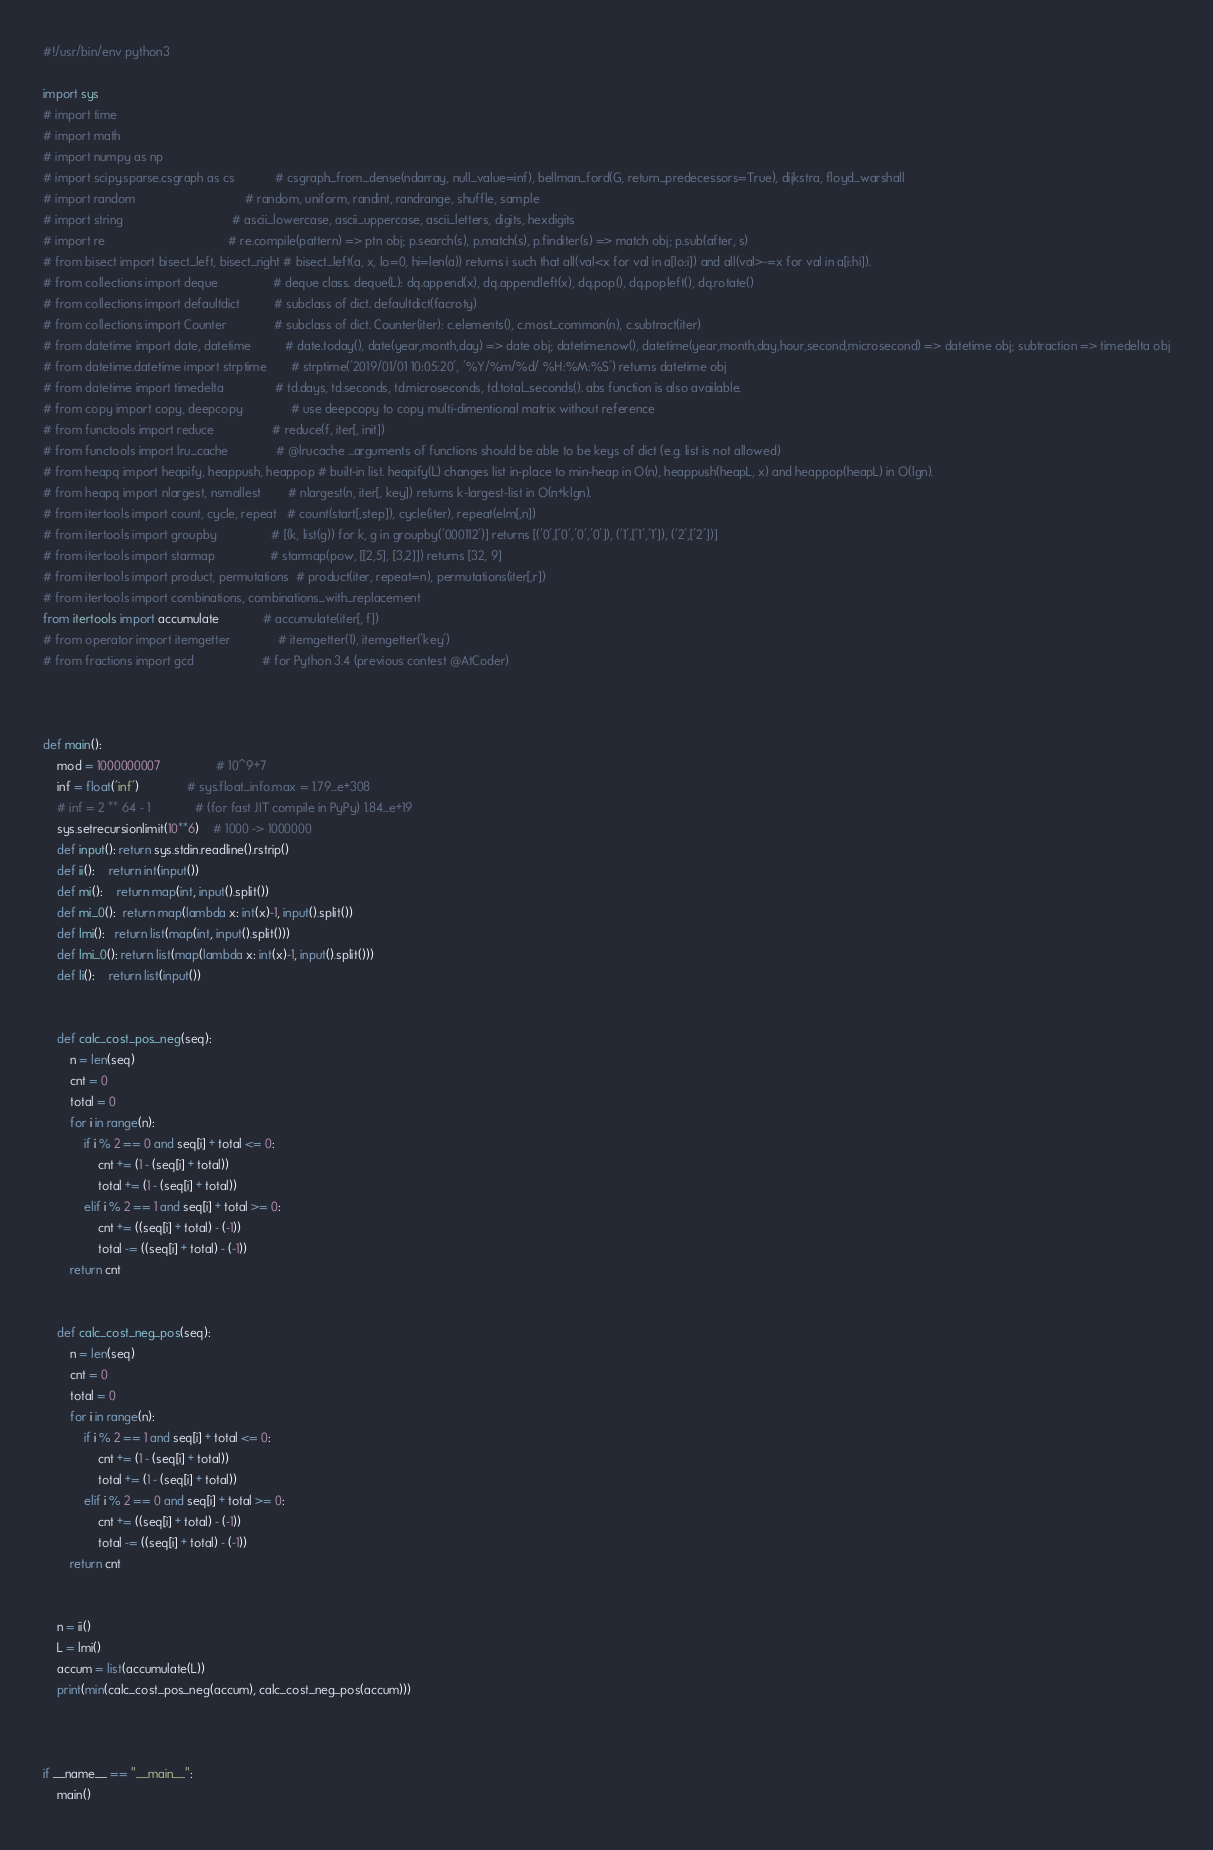<code> <loc_0><loc_0><loc_500><loc_500><_Python_>#!/usr/bin/env python3

import sys
# import time
# import math
# import numpy as np
# import scipy.sparse.csgraph as cs            # csgraph_from_dense(ndarray, null_value=inf), bellman_ford(G, return_predecessors=True), dijkstra, floyd_warshall
# import random                                # random, uniform, randint, randrange, shuffle, sample
# import string                                # ascii_lowercase, ascii_uppercase, ascii_letters, digits, hexdigits
# import re                                    # re.compile(pattern) => ptn obj; p.search(s), p.match(s), p.finditer(s) => match obj; p.sub(after, s)
# from bisect import bisect_left, bisect_right # bisect_left(a, x, lo=0, hi=len(a)) returns i such that all(val<x for val in a[lo:i]) and all(val>-=x for val in a[i:hi]).
# from collections import deque                # deque class. deque(L): dq.append(x), dq.appendleft(x), dq.pop(), dq.popleft(), dq.rotate()
# from collections import defaultdict          # subclass of dict. defaultdict(facroty)
# from collections import Counter              # subclass of dict. Counter(iter): c.elements(), c.most_common(n), c.subtract(iter)
# from datetime import date, datetime          # date.today(), date(year,month,day) => date obj; datetime.now(), datetime(year,month,day,hour,second,microsecond) => datetime obj; subtraction => timedelta obj
# from datetime.datetime import strptime       # strptime('2019/01/01 10:05:20', '%Y/%m/%d/ %H:%M:%S') returns datetime obj
# from datetime import timedelta               # td.days, td.seconds, td.microseconds, td.total_seconds(). abs function is also available.
# from copy import copy, deepcopy              # use deepcopy to copy multi-dimentional matrix without reference
# from functools import reduce                 # reduce(f, iter[, init])
# from functools import lru_cache              # @lrucache ...arguments of functions should be able to be keys of dict (e.g. list is not allowed)
# from heapq import heapify, heappush, heappop # built-in list. heapify(L) changes list in-place to min-heap in O(n), heappush(heapL, x) and heappop(heapL) in O(lgn).
# from heapq import nlargest, nsmallest        # nlargest(n, iter[, key]) returns k-largest-list in O(n+klgn).
# from itertools import count, cycle, repeat   # count(start[,step]), cycle(iter), repeat(elm[,n])
# from itertools import groupby                # [(k, list(g)) for k, g in groupby('000112')] returns [('0',['0','0','0']), ('1',['1','1']), ('2',['2'])]
# from itertools import starmap                # starmap(pow, [[2,5], [3,2]]) returns [32, 9]
# from itertools import product, permutations  # product(iter, repeat=n), permutations(iter[,r])
# from itertools import combinations, combinations_with_replacement
from itertools import accumulate             # accumulate(iter[, f])
# from operator import itemgetter              # itemgetter(1), itemgetter('key')
# from fractions import gcd                    # for Python 3.4 (previous contest @AtCoder)



def main():
    mod = 1000000007                # 10^9+7
    inf = float('inf')              # sys.float_info.max = 1.79...e+308
    # inf = 2 ** 64 - 1             # (for fast JIT compile in PyPy) 1.84...e+19
    sys.setrecursionlimit(10**6)    # 1000 -> 1000000
    def input(): return sys.stdin.readline().rstrip()
    def ii():    return int(input())
    def mi():    return map(int, input().split())
    def mi_0():  return map(lambda x: int(x)-1, input().split())
    def lmi():   return list(map(int, input().split()))
    def lmi_0(): return list(map(lambda x: int(x)-1, input().split()))
    def li():    return list(input())
    
    
    def calc_cost_pos_neg(seq):
        n = len(seq)
        cnt = 0
        total = 0
        for i in range(n):
            if i % 2 == 0 and seq[i] + total <= 0:
                cnt += (1 - (seq[i] + total))
                total += (1 - (seq[i] + total))
            elif i % 2 == 1 and seq[i] + total >= 0:
                cnt += ((seq[i] + total) - (-1))
                total -= ((seq[i] + total) - (-1))
        return cnt
    
    
    def calc_cost_neg_pos(seq):
        n = len(seq)
        cnt = 0
        total = 0
        for i in range(n):
            if i % 2 == 1 and seq[i] + total <= 0:
                cnt += (1 - (seq[i] + total))
                total += (1 - (seq[i] + total))
            elif i % 2 == 0 and seq[i] + total >= 0:
                cnt += ((seq[i] + total) - (-1))
                total -= ((seq[i] + total) - (-1))
        return cnt    

    
    n = ii()
    L = lmi()
    accum = list(accumulate(L))
    print(min(calc_cost_pos_neg(accum), calc_cost_neg_pos(accum)))
    


if __name__ == "__main__":
    main()
</code> 